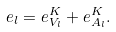<formula> <loc_0><loc_0><loc_500><loc_500>e _ { l } = e _ { V _ { l } } ^ { K } + e _ { A _ { l } } ^ { K } .</formula> 